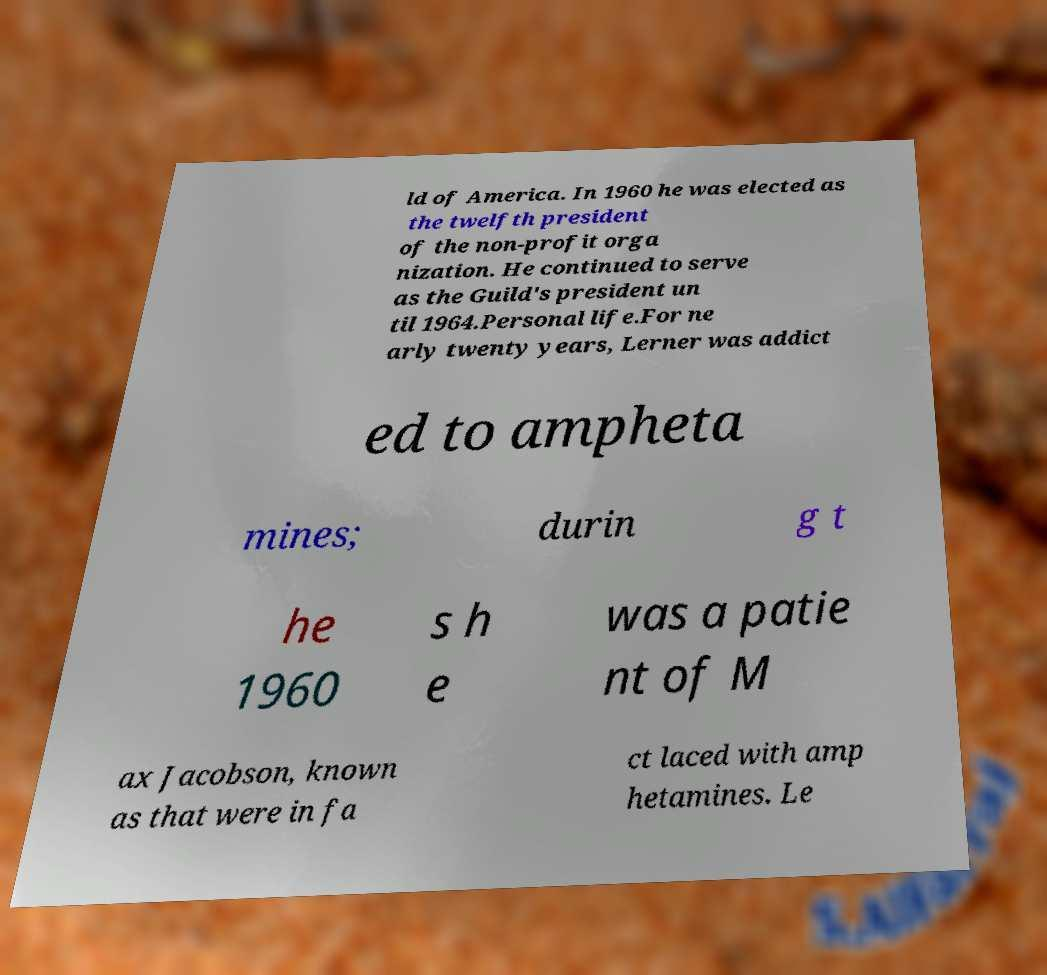Could you extract and type out the text from this image? ld of America. In 1960 he was elected as the twelfth president of the non-profit orga nization. He continued to serve as the Guild's president un til 1964.Personal life.For ne arly twenty years, Lerner was addict ed to ampheta mines; durin g t he 1960 s h e was a patie nt of M ax Jacobson, known as that were in fa ct laced with amp hetamines. Le 